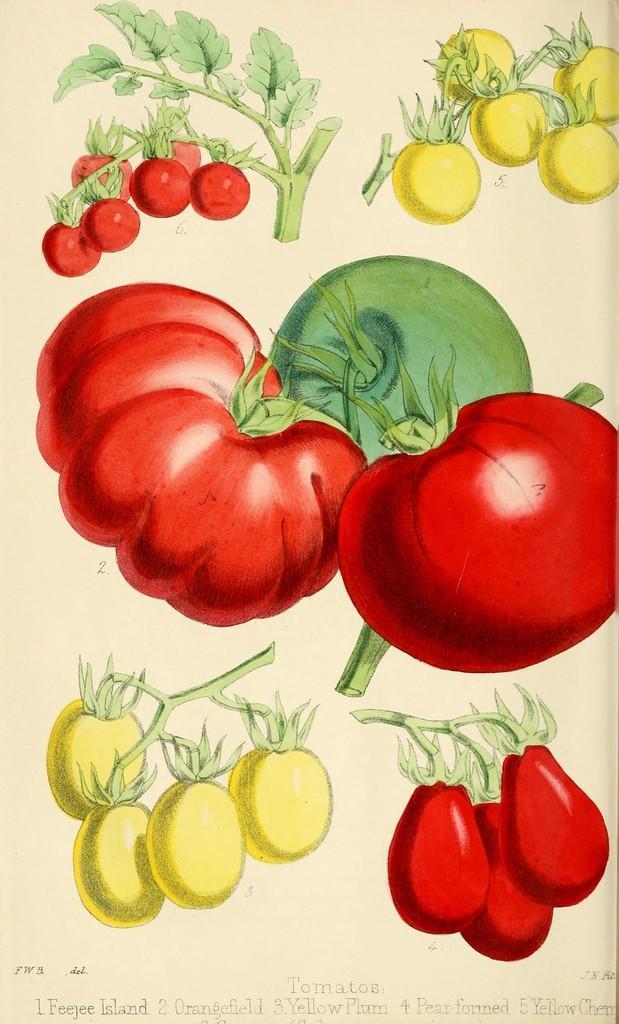Describe this image in one or two sentences. In this image I can see depiction of leaves and of few vegetables. On the bottom side of this image I can see something is written. 